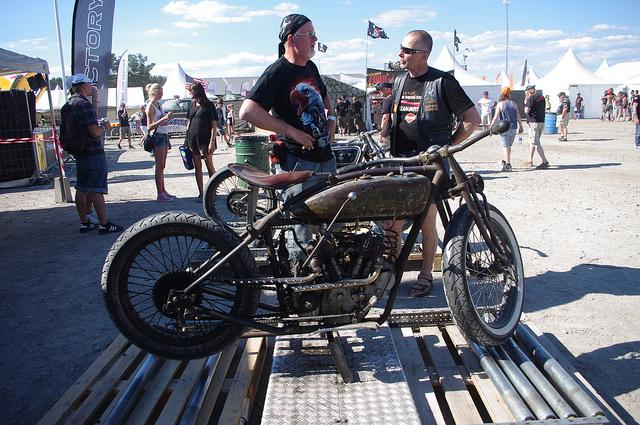What material are the pipes which are holding up the old bike? steel 